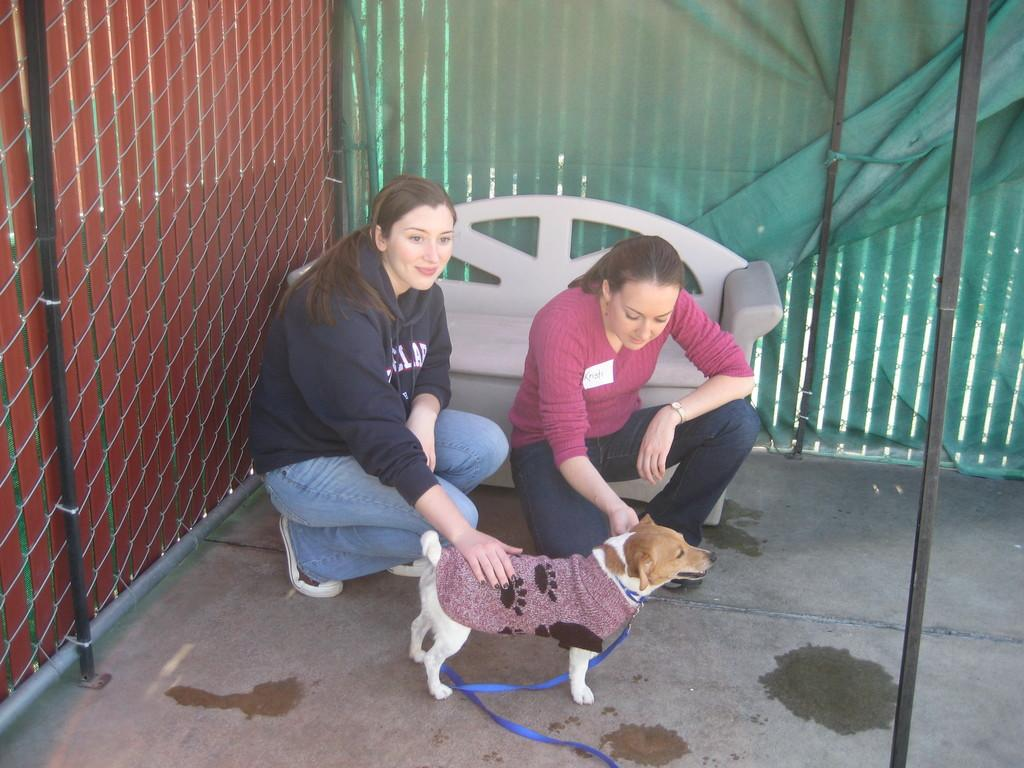How many people are in the image? There are two women in the image. What are the women doing in the image? The women are sitting and kissing a dog. What type of apple is being used to attack the dog in the image? There is no apple or attack present in the image; the women are simply kissing the dog. 